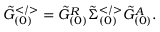<formula> <loc_0><loc_0><loc_500><loc_500>\tilde { G } _ { ( 0 ) } ^ { < / > } = \tilde { G } _ { ( 0 ) } ^ { R } \tilde { \Sigma } _ { ( 0 ) } ^ { < / > } \tilde { G } _ { ( 0 ) } ^ { A } .</formula> 